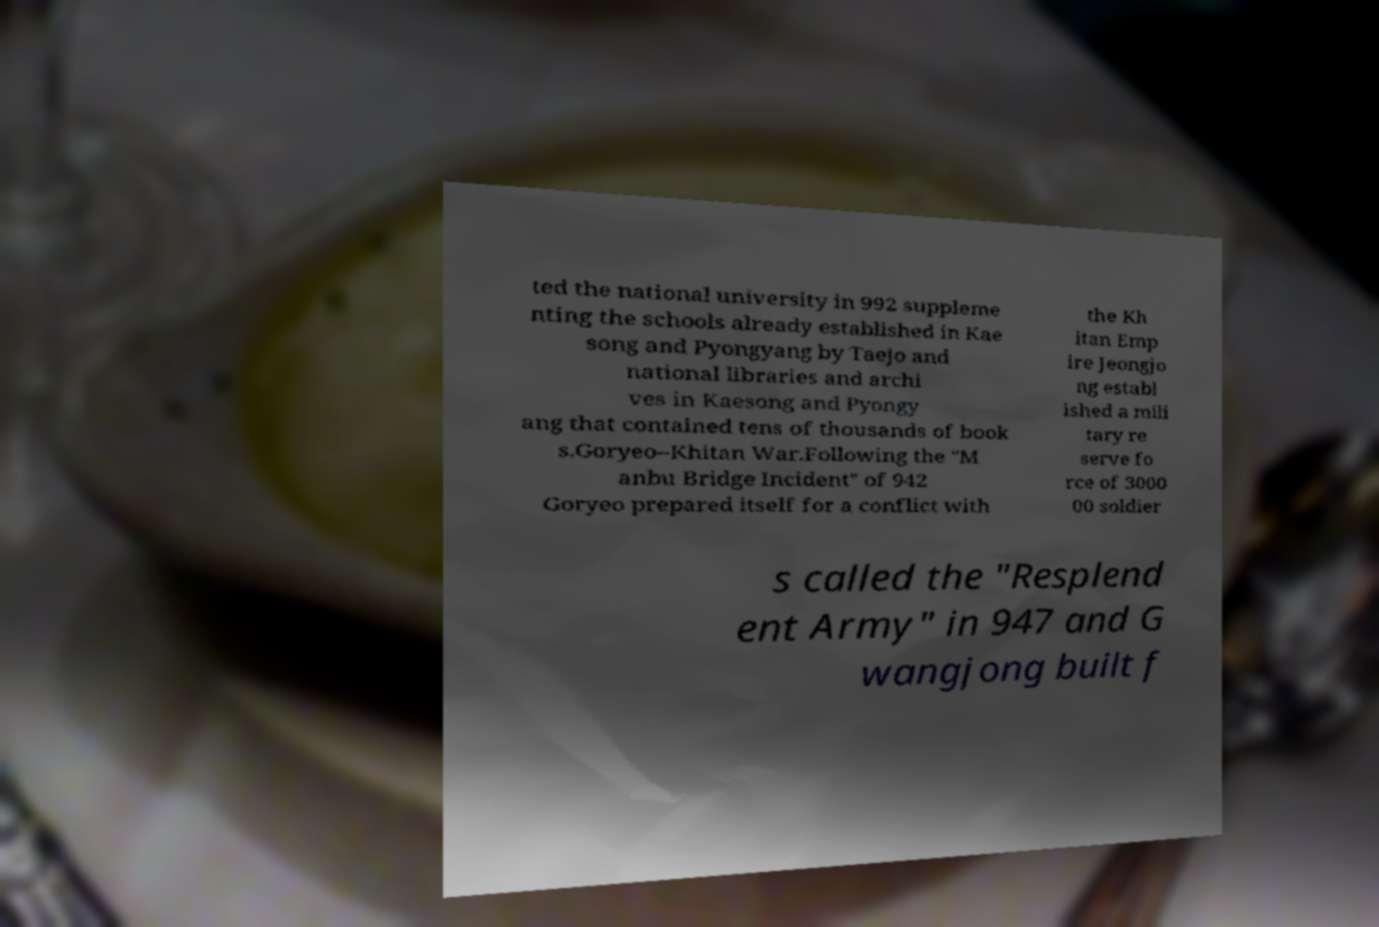What messages or text are displayed in this image? I need them in a readable, typed format. ted the national university in 992 suppleme nting the schools already established in Kae song and Pyongyang by Taejo and national libraries and archi ves in Kaesong and Pyongy ang that contained tens of thousands of book s.Goryeo–Khitan War.Following the "M anbu Bridge Incident" of 942 Goryeo prepared itself for a conflict with the Kh itan Emp ire Jeongjo ng establ ished a mili tary re serve fo rce of 3000 00 soldier s called the "Resplend ent Army" in 947 and G wangjong built f 